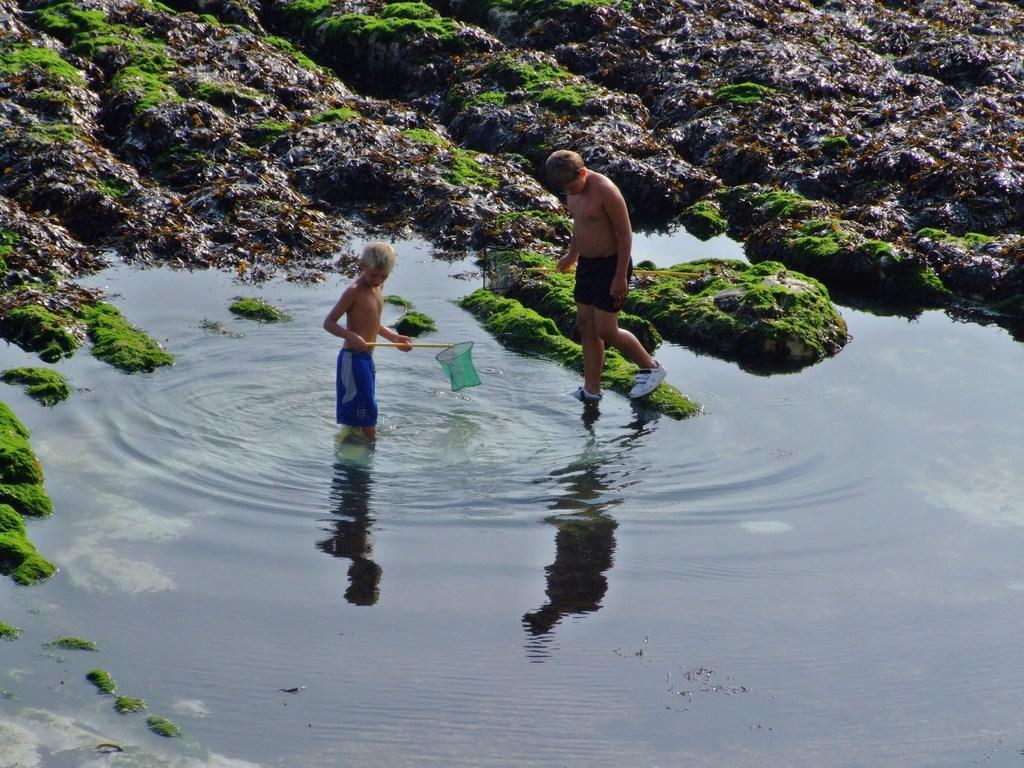How many people are present in the image? There are two people standing in the image. What are the people holding in the image? The people are holding something, but the specific object is not mentioned in the facts. What type of natural environment is visible in the image? There is water, grass, and a rock visible in the image, suggesting a natural setting. What type of skin condition can be seen on the people in the image? There is no information about the people's skin condition in the image, so it cannot be determined. 